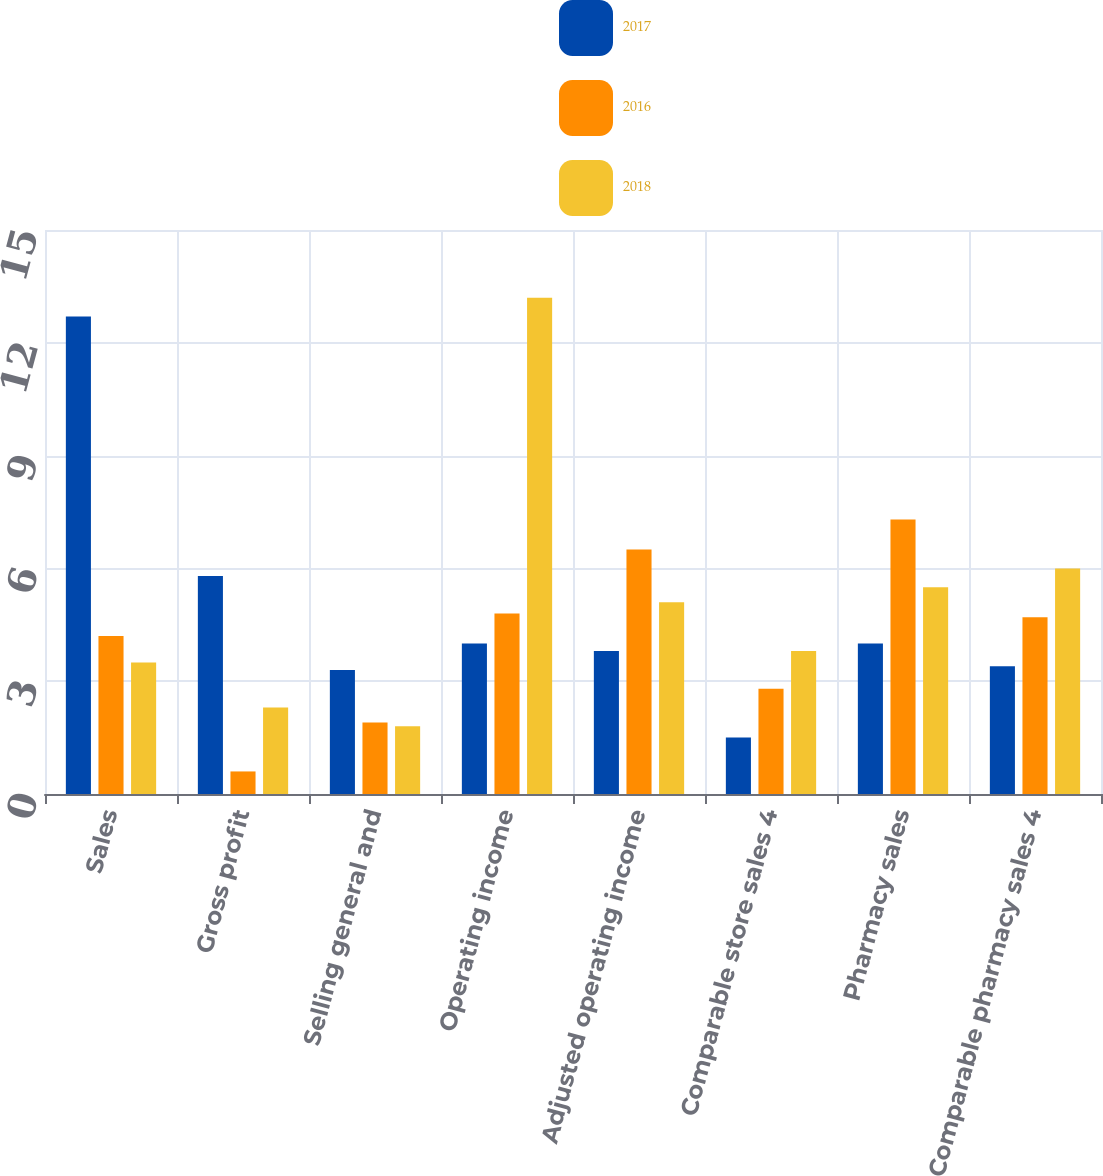<chart> <loc_0><loc_0><loc_500><loc_500><stacked_bar_chart><ecel><fcel>Sales<fcel>Gross profit<fcel>Selling general and<fcel>Operating income<fcel>Adjusted operating income<fcel>Comparable store sales 4<fcel>Pharmacy sales<fcel>Comparable pharmacy sales 4<nl><fcel>2017<fcel>12.7<fcel>5.8<fcel>3.3<fcel>4<fcel>3.8<fcel>1.5<fcel>4<fcel>3.4<nl><fcel>2016<fcel>4.2<fcel>0.6<fcel>1.9<fcel>4.8<fcel>6.5<fcel>2.8<fcel>7.3<fcel>4.7<nl><fcel>2018<fcel>3.5<fcel>2.3<fcel>1.8<fcel>13.2<fcel>5.1<fcel>3.8<fcel>5.5<fcel>6<nl></chart> 